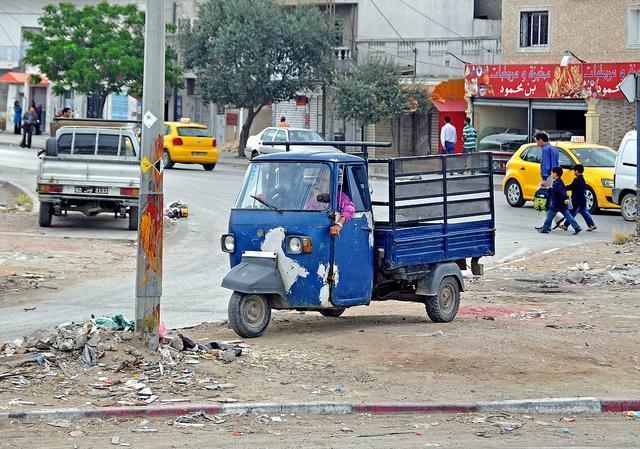How many trucks can you see?
Give a very brief answer. 2. How many cars are in the photo?
Give a very brief answer. 2. 